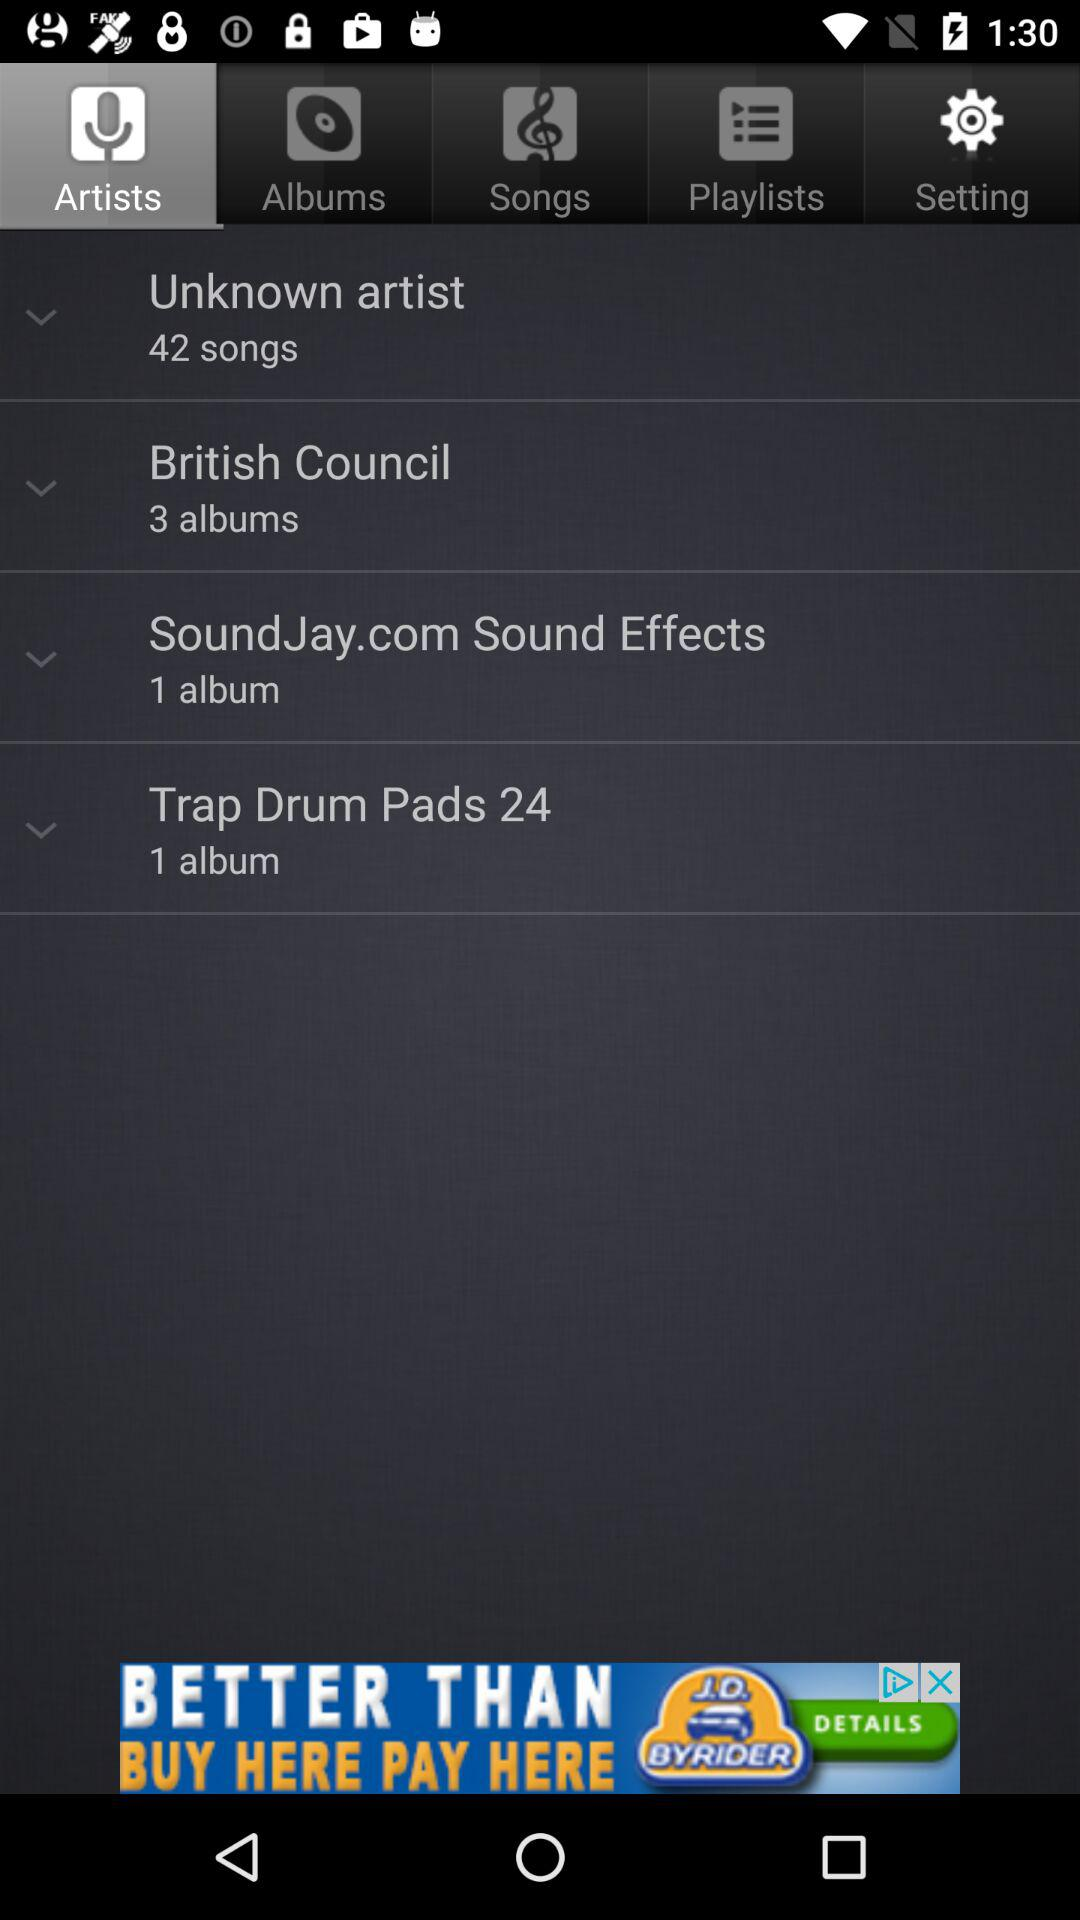How many more albums does British Council have than Trap Drum Pads?
Answer the question using a single word or phrase. 2 